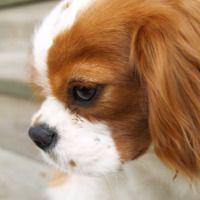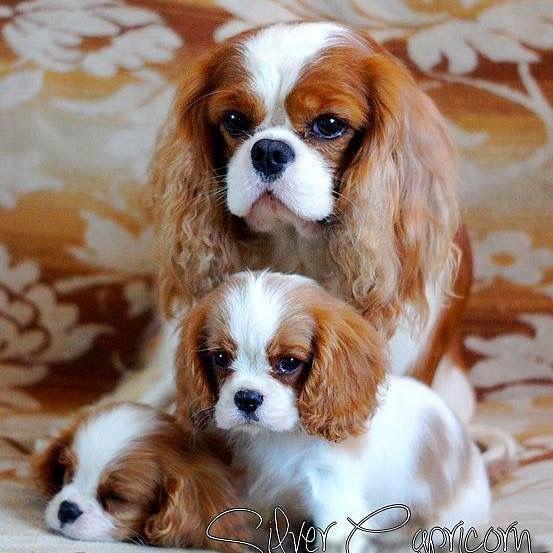The first image is the image on the left, the second image is the image on the right. Analyze the images presented: Is the assertion "One of the puppies is laying the side of its head against a blanket." valid? Answer yes or no. No. 